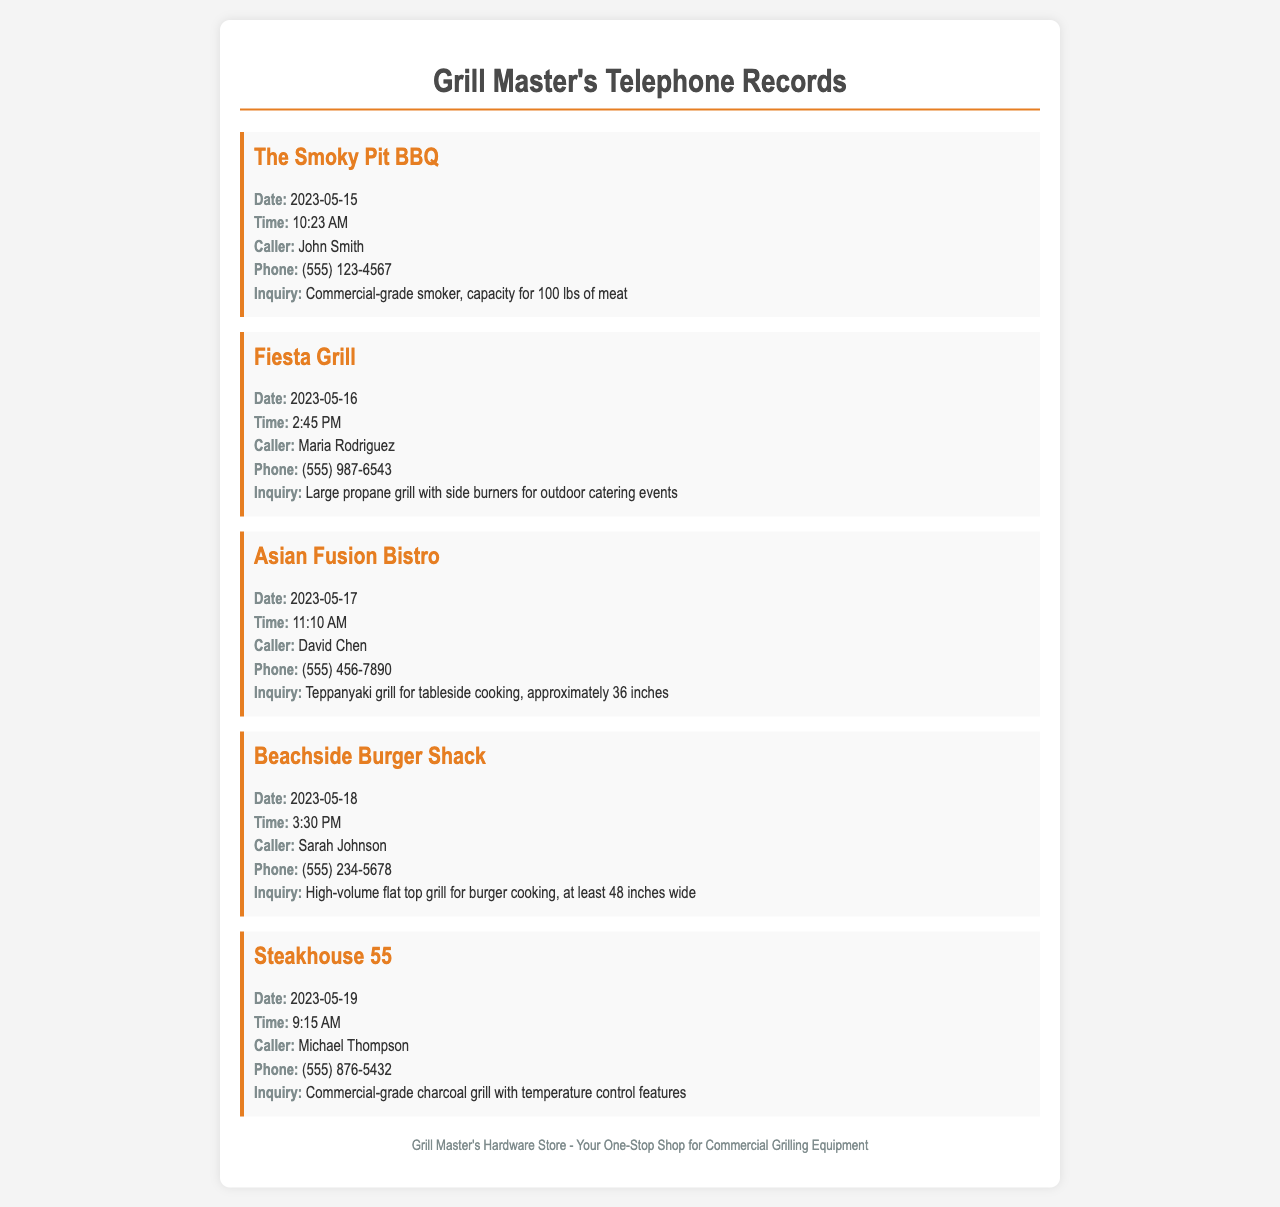What is the name of the caller from The Smoky Pit BBQ? The call record for The Smoky Pit BBQ lists John Smith as the caller.
Answer: John Smith What date did Fiesta Grill call? The record shows that Fiesta Grill made an inquiry on May 16, 2023.
Answer: 2023-05-16 What type of grill does Asian Fusion Bistro inquire about? The inquiry from Asian Fusion Bistro specifically mentions a Teppanyaki grill for tableside cooking.
Answer: Teppanyaki grill How many inches wide does Beachside Burger Shack need their flat top grill? The inquiry indicates that Beachside Burger Shack requires a flat top grill that is at least 48 inches wide.
Answer: 48 inches What is the contact phone number for Steakhouse 55? The record provides the phone number for Steakhouse 55 as (555) 876-5432.
Answer: (555) 876-5432 Which restaurant is looking for a large propane grill? Fiesta Grill is the restaurant inquiring about a large propane grill with side burners.
Answer: Fiesta Grill How many pounds of meat does The Smoky Pit BBQ need the smoker to accommodate? The inquiry specifies that The Smoky Pit BBQ needs a smoker with the capacity for 100 lbs of meat.
Answer: 100 lbs What is the time of the call from Beachside Burger Shack? The record indicates that the call from Beachside Burger Shack was made at 3:30 PM.
Answer: 3:30 PM Who called to inquire about a charcoal grill? The inquiry regarding a charcoal grill was made by Michael Thompson from Steakhouse 55.
Answer: Michael Thompson 